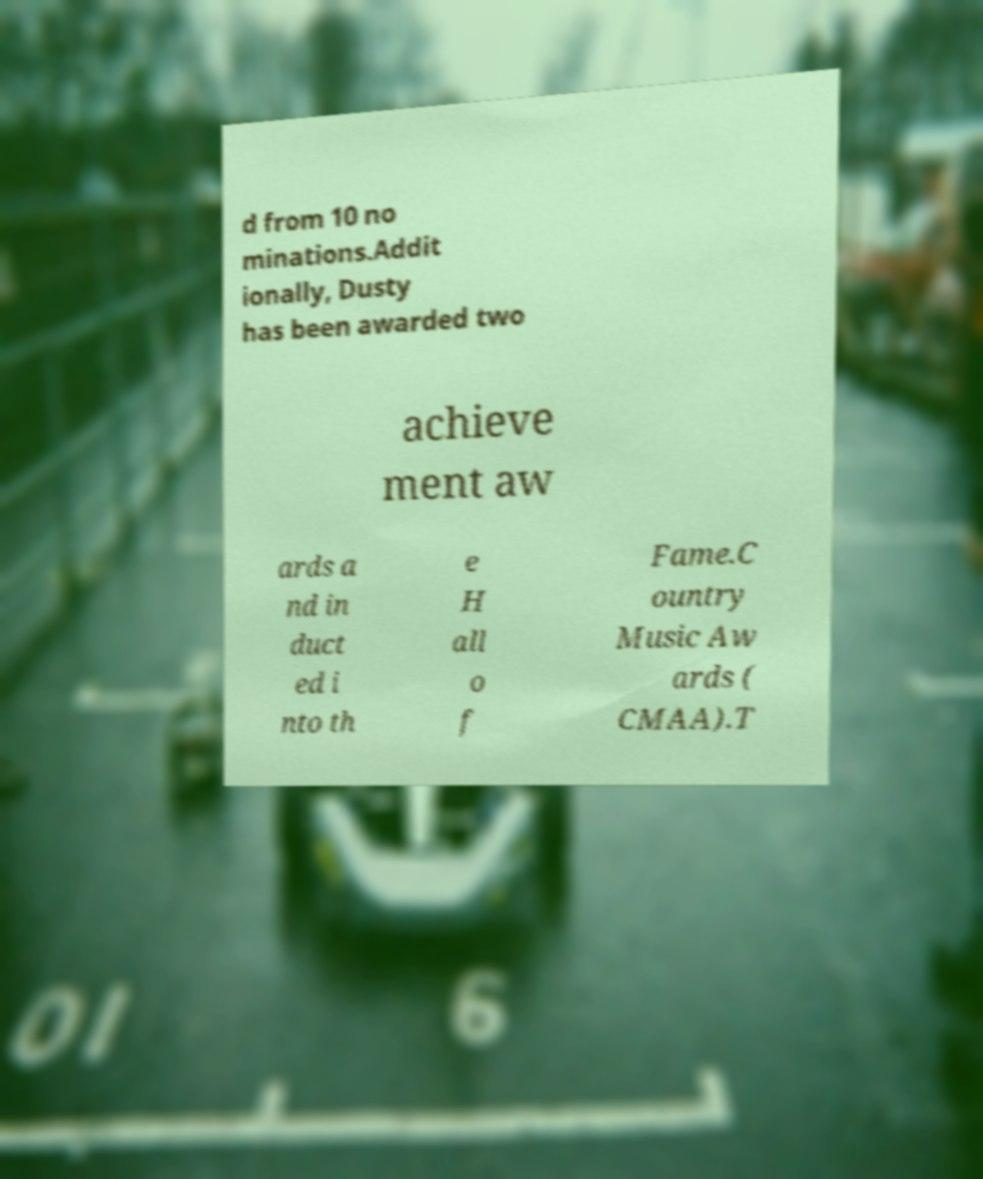I need the written content from this picture converted into text. Can you do that? d from 10 no minations.Addit ionally, Dusty has been awarded two achieve ment aw ards a nd in duct ed i nto th e H all o f Fame.C ountry Music Aw ards ( CMAA).T 